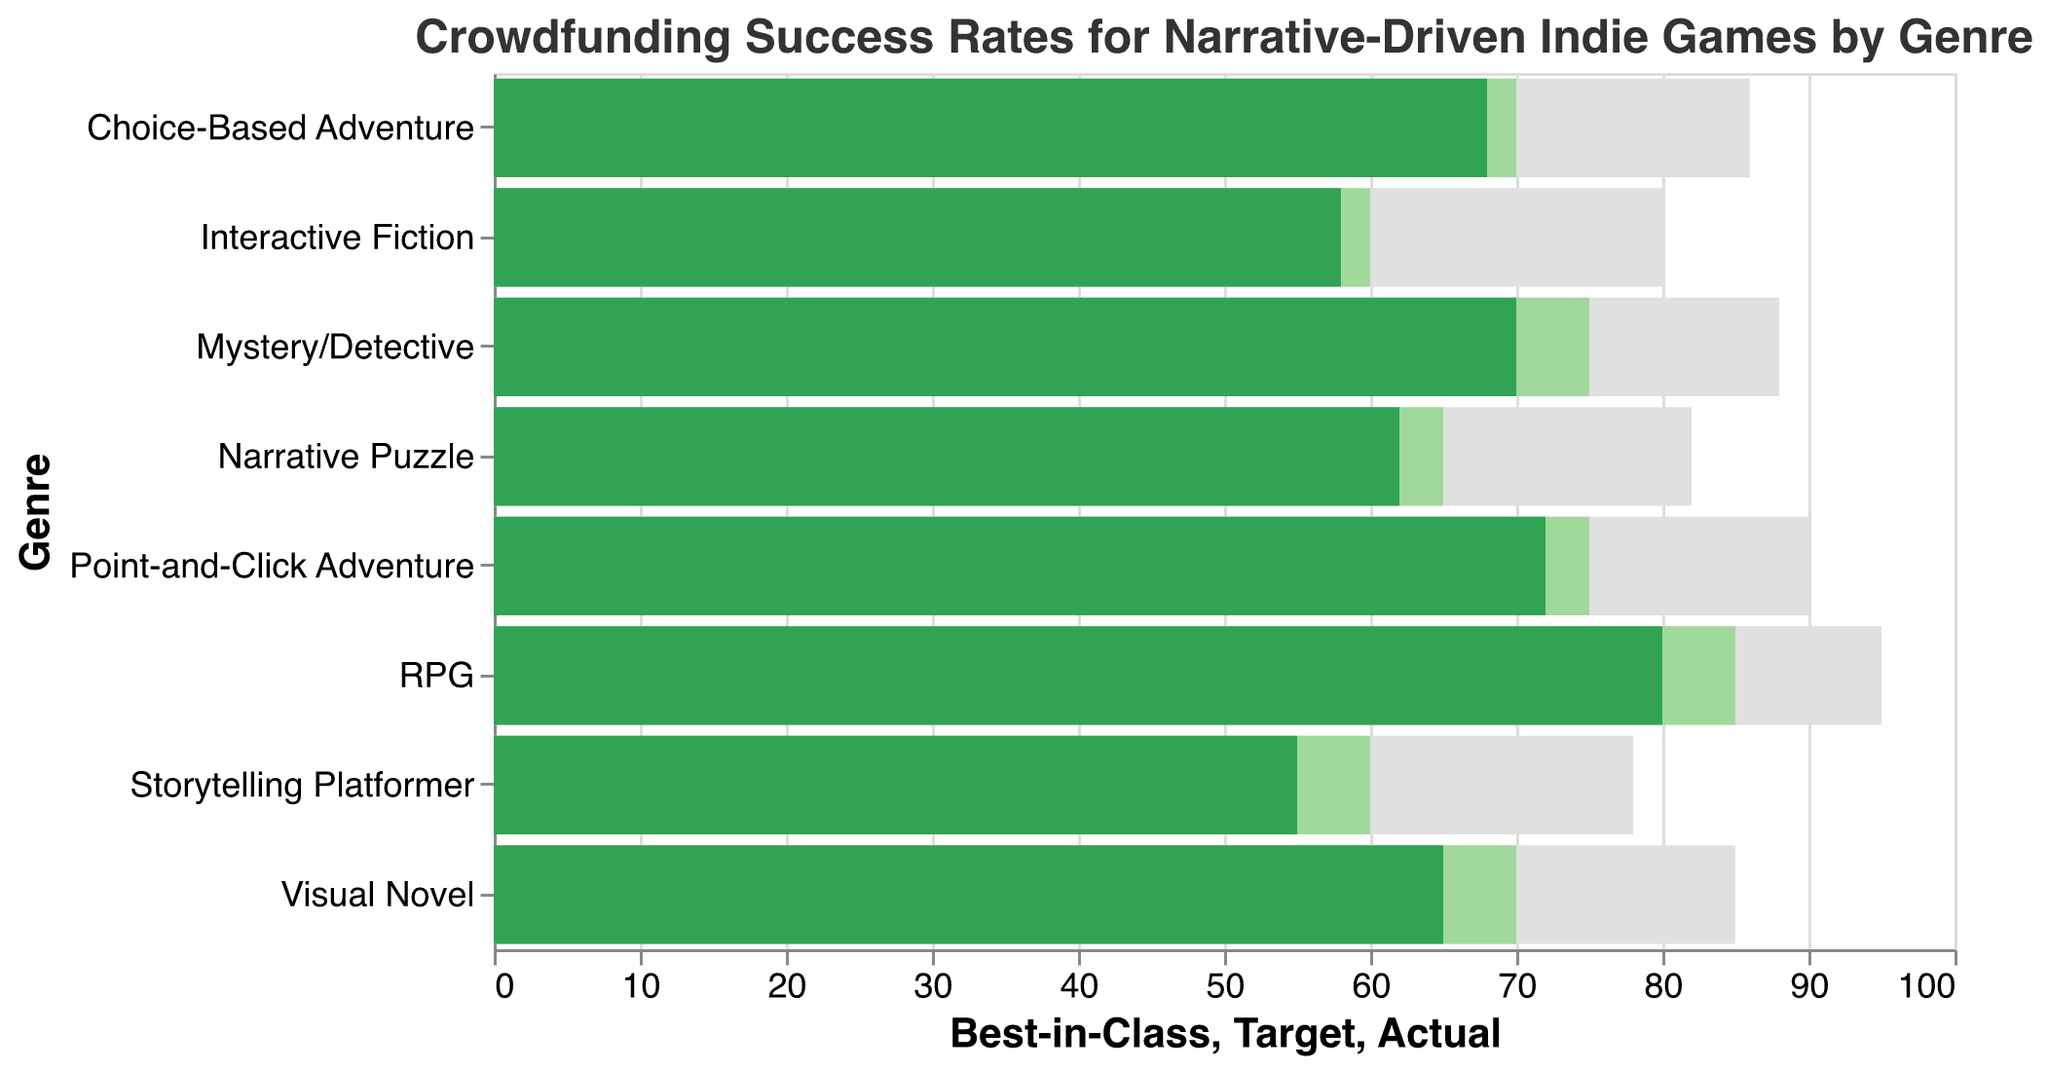What is the title of the figure? The title of the figure is displayed at the top of the chart. It reads "Crowdfunding Success Rates for Narrative-Driven Indie Games by Genre."
Answer: Crowdfunding Success Rates for Narrative-Driven Indie Games by Genre Which genre has the highest actual success rate? By examining the "Actual" bars, the genre with the highest success rate is the one with the longest green bar.
Answer: RPG How does the actual success rate of Visual Novel compare to its target? Visual Novel's "Actual" bar should be compared directly with its "Target" bar, which is slightly shorter.
Answer: Less than target What is the gap between the actual success rate of Interactive Fiction and the best-in-class rate for the same genre? To find the gap, subtract the "Actual" value from the "Best-in-Class" value for Interactive Fiction (80 - 58).
Answer: 22 Which genre has the smallest gap between its actual success rate and its target rate? Calculate the differences between "Actual" and "Target" for all genres and compare the values. The genre with the smallest difference is the answer.
Answer: Interactive Fiction (2 points) What is the average target success rate across all genres? Add all the "Target" values and divide by the number of genres (70 + 75 + 60 + 85 + 65 + 75 + 70 + 60) / 8.
Answer: 70 Of all the genres, which one is closest to meeting the best-in-class success rate? Subtract "Actual" values from "Best-in-Class" values for all genres and compare them to find the smallest difference.
Answer: RPG (15 points difference) Compare the actual success rates of Mystery/Detective and Choice-Based Adventure genres. Which one is higher? Directly compare the "Actual" values for Mystery/Detective (70) and Choice-Based Adventure (68) genres.
Answer: Mystery/Detective Is there any genre where the actual success rate is equal to the target rate? Check if any genre has the same value for both "Actual" and "Target" bars.
Answer: No How does the success rate of Point-and-Click Adventure games compare to Storytelling Platformer games in terms of meeting their target rates? Compare the difference between the "Actual" and "Target" rates for both genres. Point-and-Click Adventure is 3 points below the target, while Storytelling Platformer is 5 points below.
Answer: Point-and-Click Adventure is closer to its target 